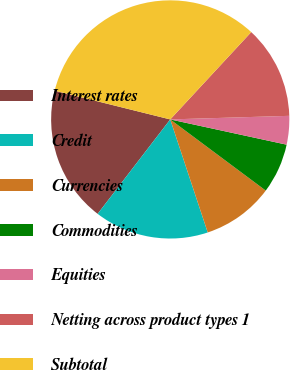Convert chart to OTSL. <chart><loc_0><loc_0><loc_500><loc_500><pie_chart><fcel>Interest rates<fcel>Credit<fcel>Currencies<fcel>Commodities<fcel>Equities<fcel>Netting across product types 1<fcel>Subtotal<nl><fcel>18.45%<fcel>15.53%<fcel>9.71%<fcel>6.79%<fcel>3.88%<fcel>12.62%<fcel>33.02%<nl></chart> 